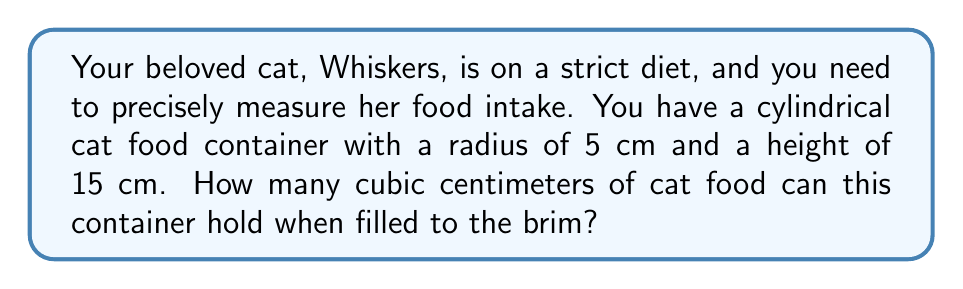What is the answer to this math problem? To calculate the volume of a cylindrical cat food container, we need to use the formula for the volume of a cylinder:

$$V = \pi r^2 h$$

Where:
$V$ = volume of the cylinder
$\pi$ = pi (approximately 3.14159)
$r$ = radius of the base of the cylinder
$h$ = height of the cylinder

Given:
$r = 5$ cm
$h = 15$ cm

Let's substitute these values into the formula:

$$V = \pi (5 \text{ cm})^2 (15 \text{ cm})$$

Now, let's calculate step by step:

1) First, calculate $r^2$:
   $5^2 = 25 \text{ cm}^2$

2) Multiply by $\pi$:
   $\pi \times 25 \text{ cm}^2 = 78.53981633974483 \text{ cm}^2$

3) Finally, multiply by the height:
   $78.53981633974483 \text{ cm}^2 \times 15 \text{ cm} = 1178.0972450961724 \text{ cm}^3$

4) Round to two decimal places:
   $1178.10 \text{ cm}^3$

Therefore, the cylindrical cat food container can hold approximately 1178.10 cubic centimeters of cat food when filled to the brim.
Answer: $1178.10 \text{ cm}^3$ 